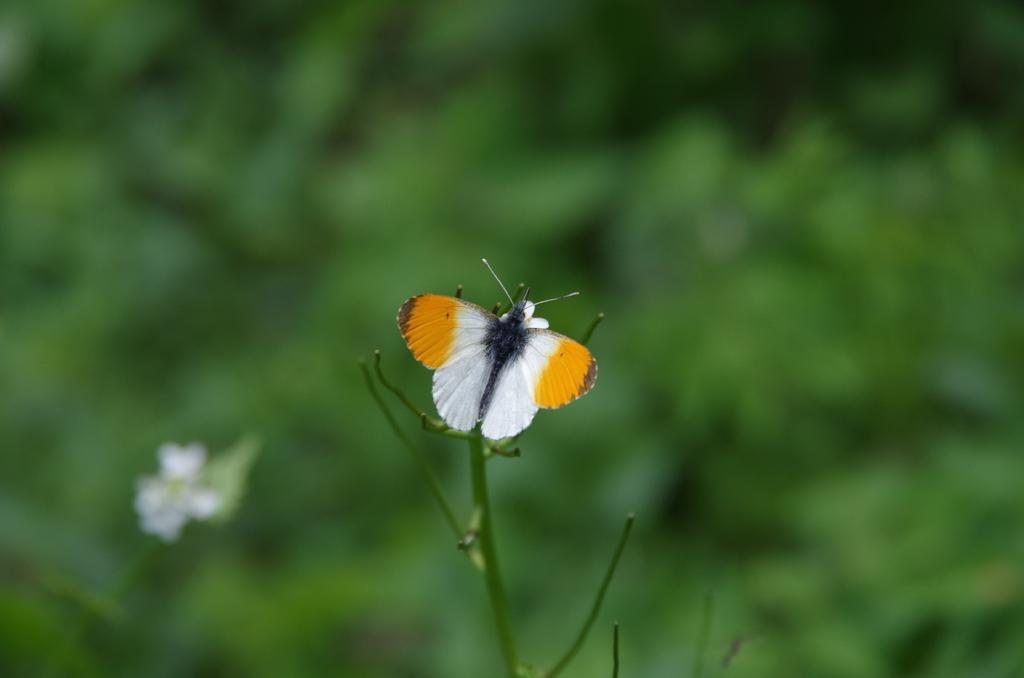What is the main subject of the image? There is a butterfly in the image. Where is the butterfly located? The butterfly is on a plant. Can you describe the background of the image? The background of the image is blurred. What type of company is mentioned in the image? There is no company mentioned in the image; it features a butterfly on a plant with a blurred background. What color is the sock that the butterfly is wearing in the image? There is no sock present in the image, as butterflies do not wear socks. 